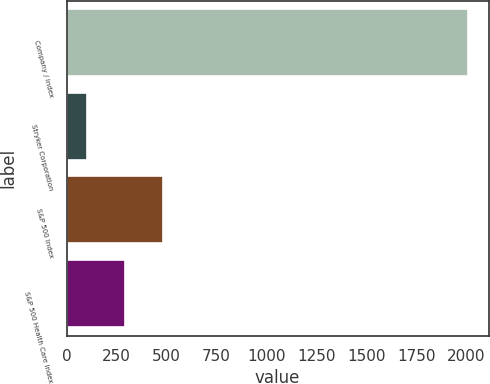<chart> <loc_0><loc_0><loc_500><loc_500><bar_chart><fcel>Company / Index<fcel>Stryker Corporation<fcel>S&P 500 Index<fcel>S&P 500 Health Care Index<nl><fcel>2011<fcel>101.29<fcel>483.23<fcel>292.26<nl></chart> 